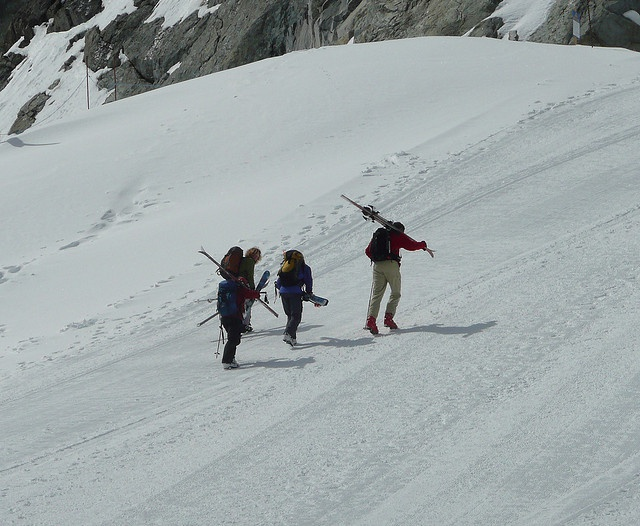Describe the objects in this image and their specific colors. I can see people in black, gray, darkgreen, and maroon tones, people in black, gray, and navy tones, people in black, gray, darkgray, and maroon tones, backpack in black, darkgray, and olive tones, and backpack in black, navy, blue, and gray tones in this image. 